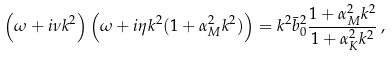<formula> <loc_0><loc_0><loc_500><loc_500>\left ( \omega + i \nu k ^ { 2 } \right ) \left ( \omega + i \eta k ^ { 2 } ( 1 + \alpha _ { M } ^ { 2 } k ^ { 2 } ) \right ) = k ^ { 2 } \bar { b } _ { 0 } ^ { 2 } \frac { 1 + \alpha _ { M } ^ { 2 } k ^ { 2 } } { 1 + \alpha _ { K } ^ { 2 } k ^ { 2 } } \, ,</formula> 